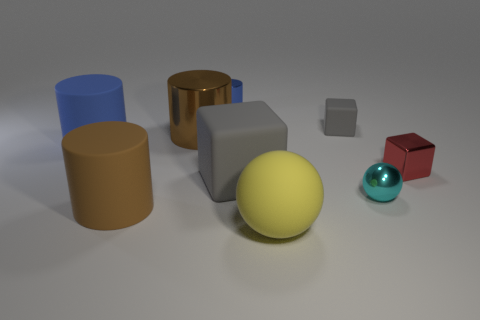What number of things are either blocks or brown objects in front of the small cyan shiny ball?
Make the answer very short. 4. The big object that is made of the same material as the tiny sphere is what color?
Make the answer very short. Brown. How many objects are gray objects or blue matte cylinders?
Provide a succinct answer. 3. There is a cylinder that is the same size as the cyan sphere; what color is it?
Provide a succinct answer. Blue. What number of objects are tiny gray things that are behind the small red block or large blocks?
Give a very brief answer. 2. How many other objects are the same size as the cyan thing?
Give a very brief answer. 3. What size is the matte block that is left of the small gray matte thing?
Your answer should be compact. Large. There is a large brown thing that is the same material as the yellow sphere; what is its shape?
Provide a succinct answer. Cylinder. Is there any other thing of the same color as the rubber ball?
Ensure brevity in your answer.  No. What color is the shiny cylinder that is in front of the small object that is left of the big yellow rubber thing?
Make the answer very short. Brown. 